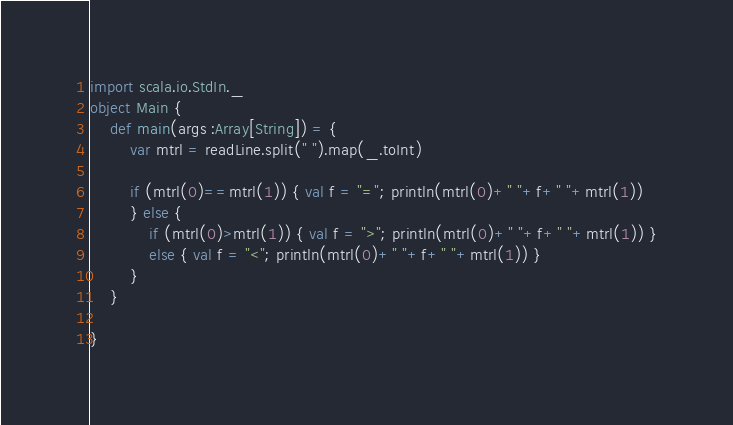<code> <loc_0><loc_0><loc_500><loc_500><_Scala_>import scala.io.StdIn._
object Main {
	def main(args :Array[String]) = {
		var mtrl = readLine.split(" ").map(_.toInt)
		
		if (mtrl(0)==mtrl(1)) { val f = "="; println(mtrl(0)+" "+f+" "+mtrl(1))
		} else {
			if (mtrl(0)>mtrl(1)) { val f = ">"; println(mtrl(0)+" "+f+" "+mtrl(1)) }
			else { val f = "<"; println(mtrl(0)+" "+f+" "+mtrl(1)) }
		}
	}
	
}</code> 